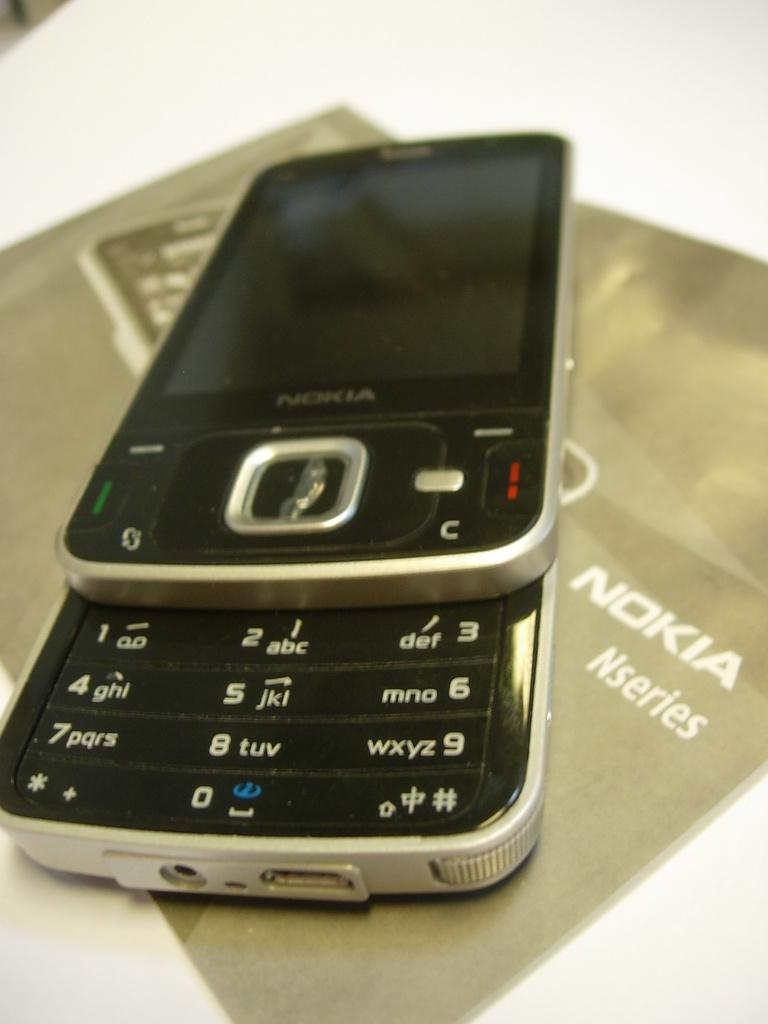<image>
Offer a succinct explanation of the picture presented. A close up of an old style sliding Nokia Nseries phone. 